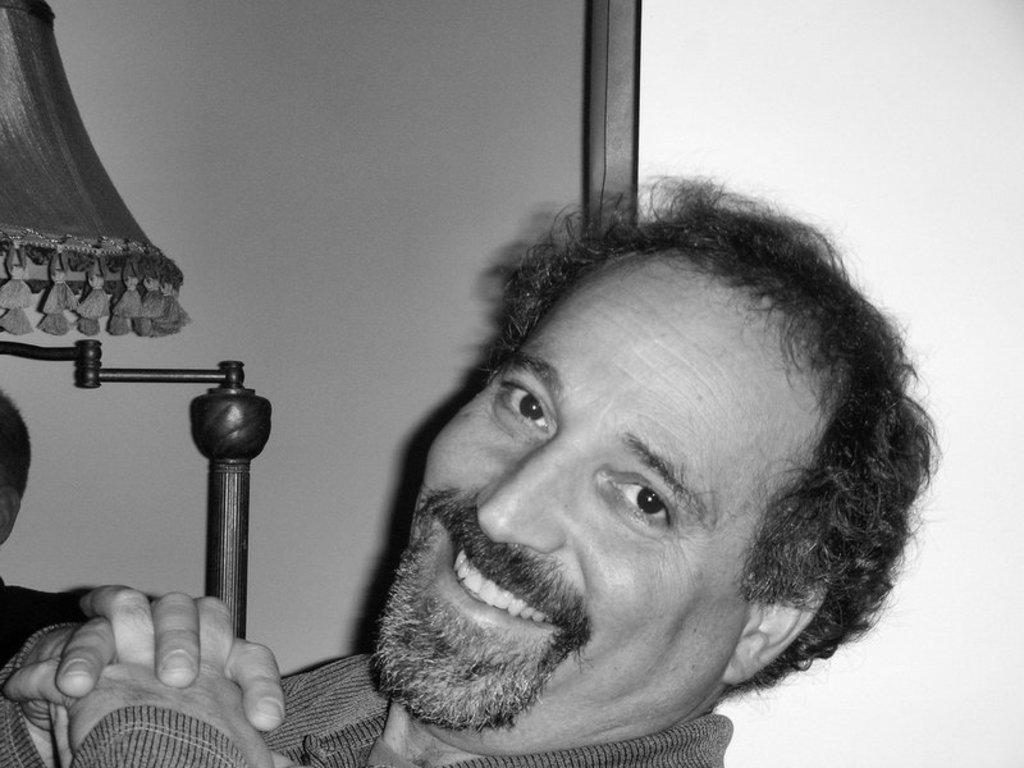How would you summarize this image in a sentence or two? In this picture I can observe a man. This man is smiling. This is a black and white image. On the left side I can observe a lamp. 